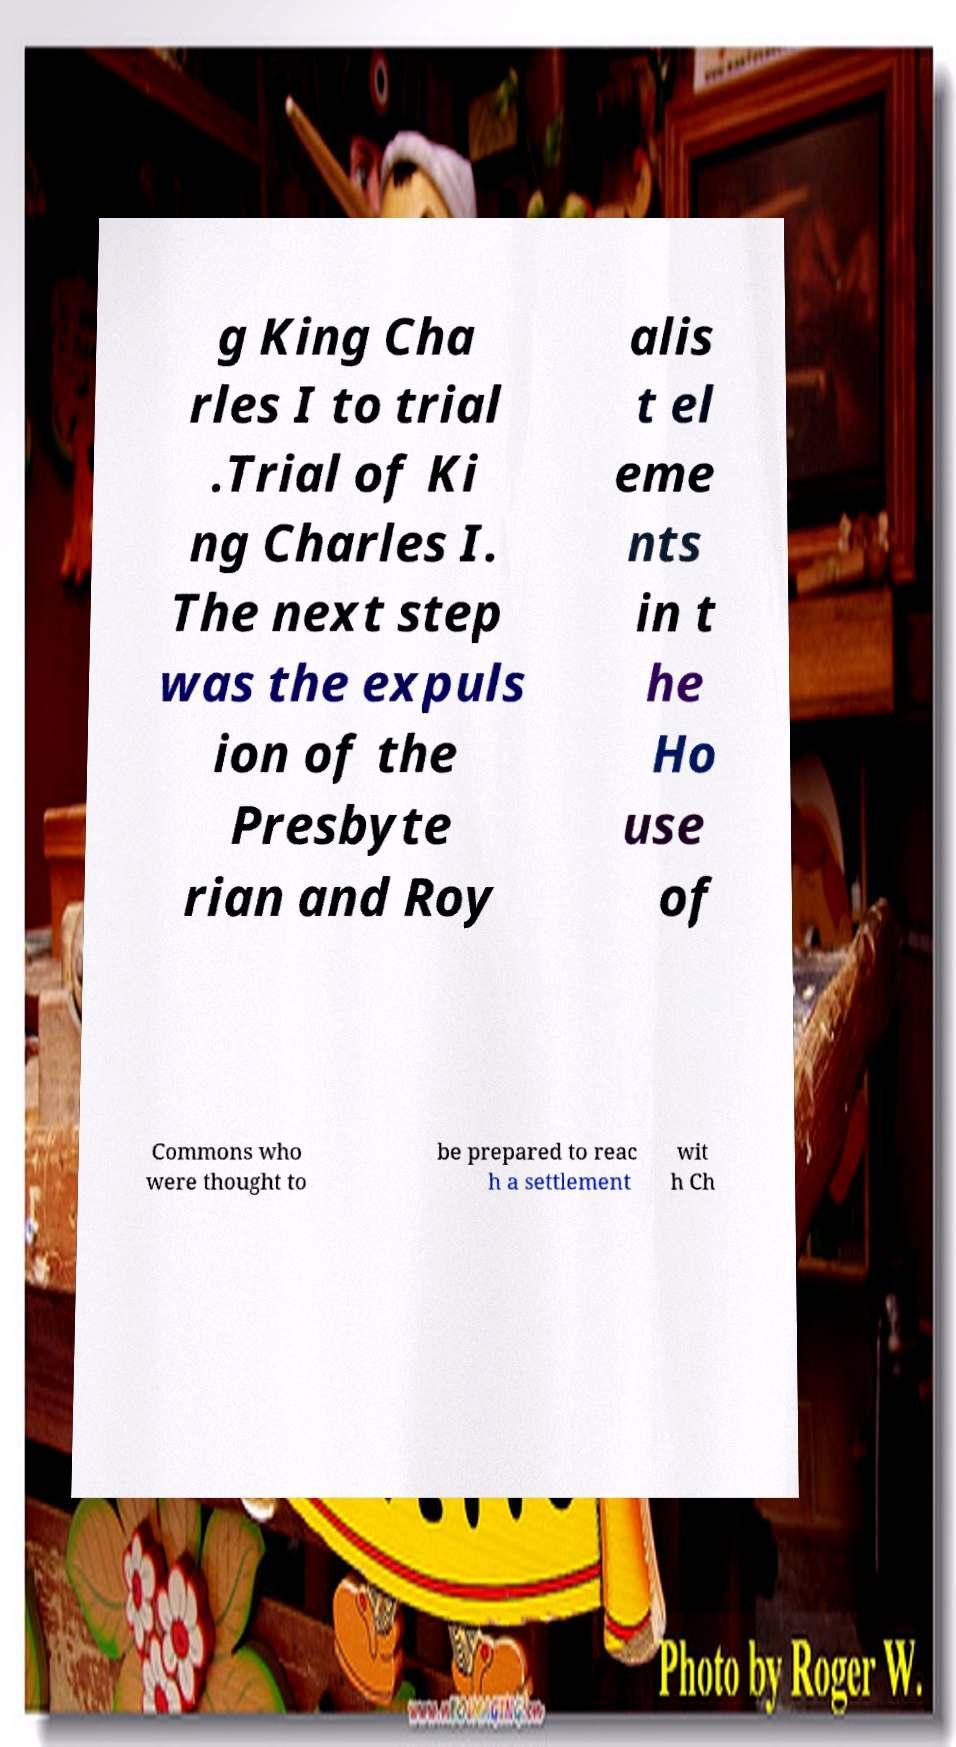Please read and relay the text visible in this image. What does it say? g King Cha rles I to trial .Trial of Ki ng Charles I. The next step was the expuls ion of the Presbyte rian and Roy alis t el eme nts in t he Ho use of Commons who were thought to be prepared to reac h a settlement wit h Ch 